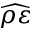<formula> <loc_0><loc_0><loc_500><loc_500>\widehat { \rho \varepsilon }</formula> 